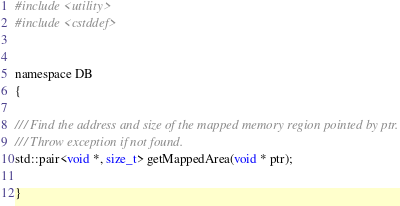<code> <loc_0><loc_0><loc_500><loc_500><_C_>#include <utility>
#include <cstddef>


namespace DB
{

/// Find the address and size of the mapped memory region pointed by ptr.
/// Throw exception if not found.
std::pair<void *, size_t> getMappedArea(void * ptr);

}
</code> 